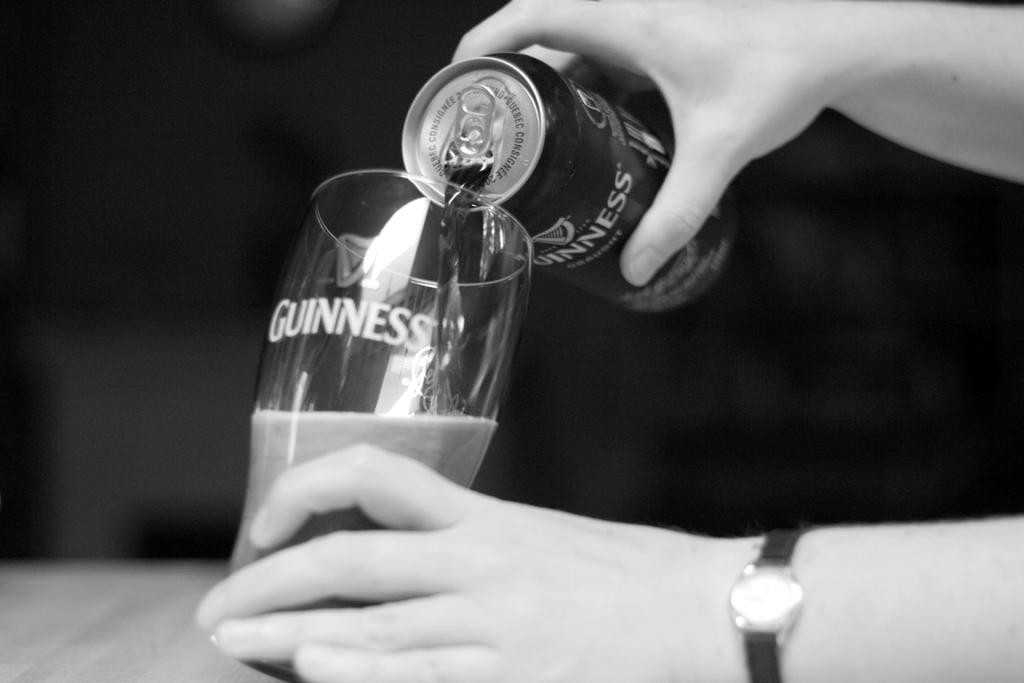What is the color scheme of the image? The image is black and white. What is the person in the image doing with their hands? The person's hands are holding a tin and a glass. What action is being performed with the tin and glass? Liquid is being poured from the tin into the glass. How would you describe the overall lighting in the image? The background of the image is dark. What type of reaction does the pet have when it sees the liquid being poured in the image? There is no pet present in the image, so it is not possible to determine any reactions. 